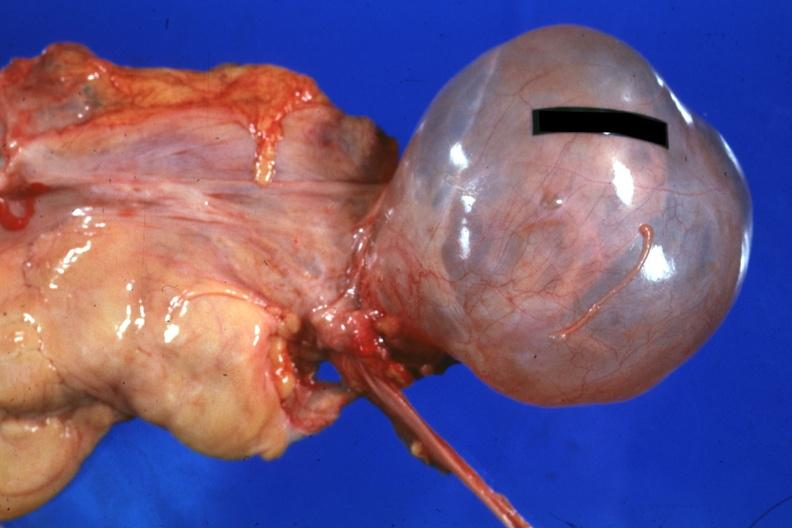s vasculature present?
Answer the question using a single word or phrase. No 